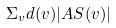<formula> <loc_0><loc_0><loc_500><loc_500>\Sigma _ { v } d ( v ) | A S ( v ) |</formula> 